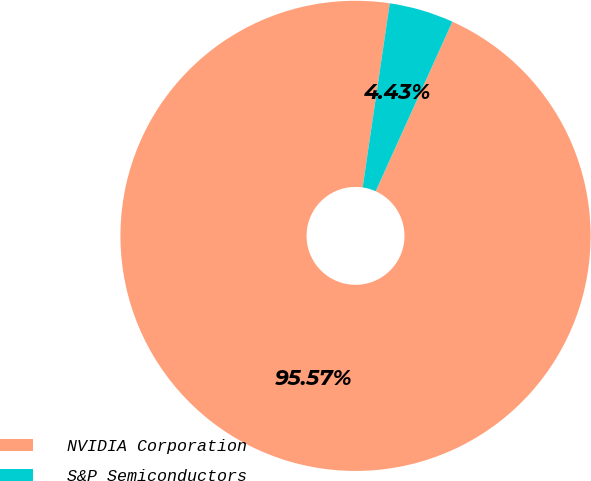Convert chart. <chart><loc_0><loc_0><loc_500><loc_500><pie_chart><fcel>NVIDIA Corporation<fcel>S&P Semiconductors<nl><fcel>95.57%<fcel>4.43%<nl></chart> 